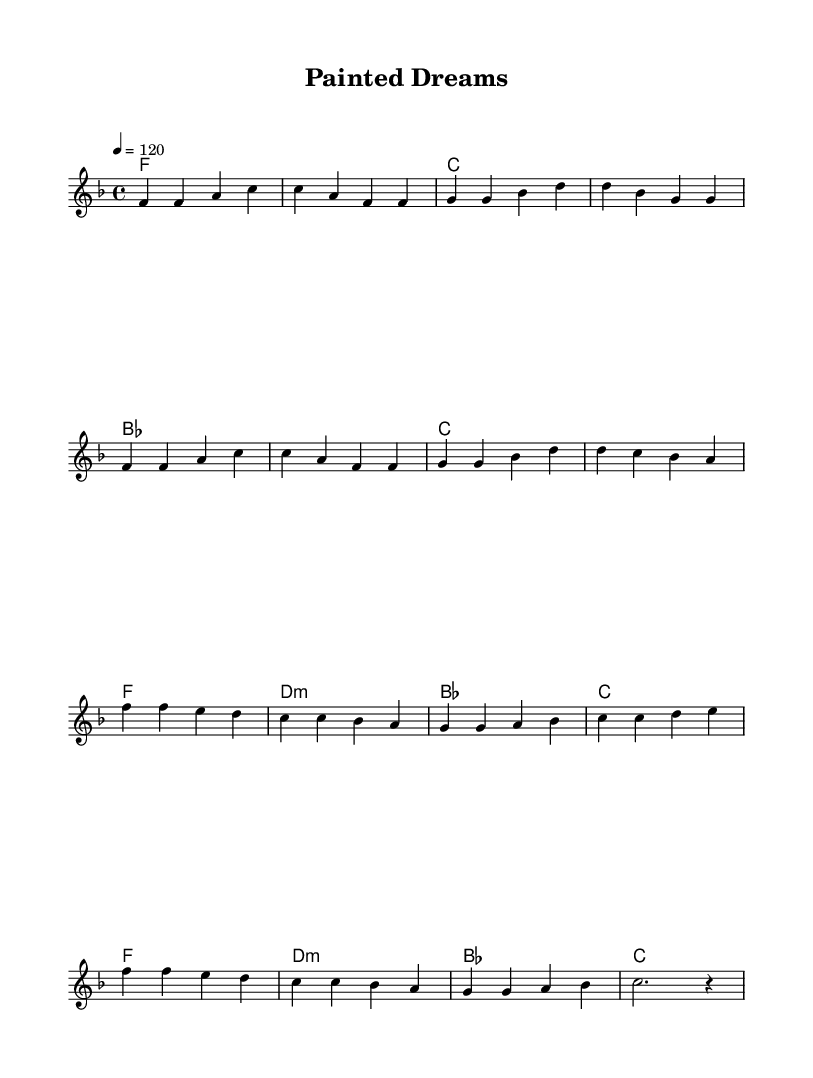What is the key signature of this music? The key signature is F major, which has one flat (B flat). This can be determined by looking at the key signature section at the beginning of the staff.
Answer: F major What is the time signature of this music? The time signature is 4/4, indicating that there are four beats in each measure, and the quarter note receives one beat. This can be identified at the start of the score where the time signature is specified.
Answer: 4/4 What is the tempo marking for this music? The tempo marking is 120 beats per minute, which indicates the speed of the piece. This is typically found at the beginning of the score, following the time signature.
Answer: 120 How many measures are in the melody section? The melody section consists of 16 measures. By counting the separate groupings made by bars, we can determine the total number.
Answer: 16 What is the last note of the chorus melody? The last note of the chorus melody is a rest, indicated by the notation at the end of the chorus section. This shows that the music pauses at this point.
Answer: rest How many chords are used in the verse section? There are four unique chords used in the verse section: F, C, B flat, and C. By analyzing the chord symbols above the melody, we can identify each chord played.
Answer: four What is the emotional tone conveyed through the harmony in the chorus? The emotional tone conveyed is melancholic, as evidenced by the use of D minor and B flat major chords, which tend to evoke feelings of sadness in music. This conclusion comes from understanding how different chord structures affect emotion.
Answer: melancholic 